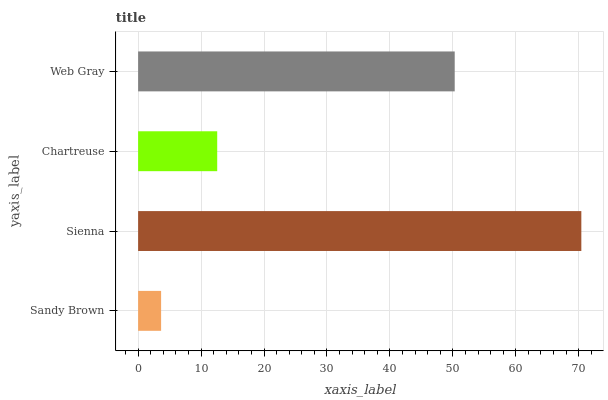Is Sandy Brown the minimum?
Answer yes or no. Yes. Is Sienna the maximum?
Answer yes or no. Yes. Is Chartreuse the minimum?
Answer yes or no. No. Is Chartreuse the maximum?
Answer yes or no. No. Is Sienna greater than Chartreuse?
Answer yes or no. Yes. Is Chartreuse less than Sienna?
Answer yes or no. Yes. Is Chartreuse greater than Sienna?
Answer yes or no. No. Is Sienna less than Chartreuse?
Answer yes or no. No. Is Web Gray the high median?
Answer yes or no. Yes. Is Chartreuse the low median?
Answer yes or no. Yes. Is Chartreuse the high median?
Answer yes or no. No. Is Sienna the low median?
Answer yes or no. No. 